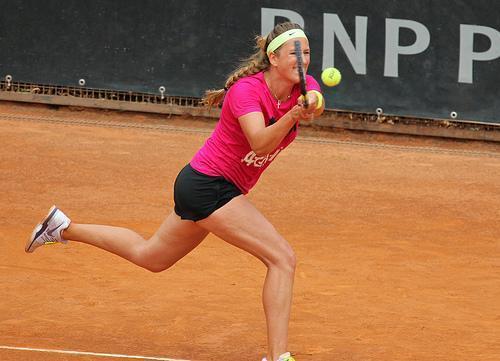How many people are in the photo?
Give a very brief answer. 1. 